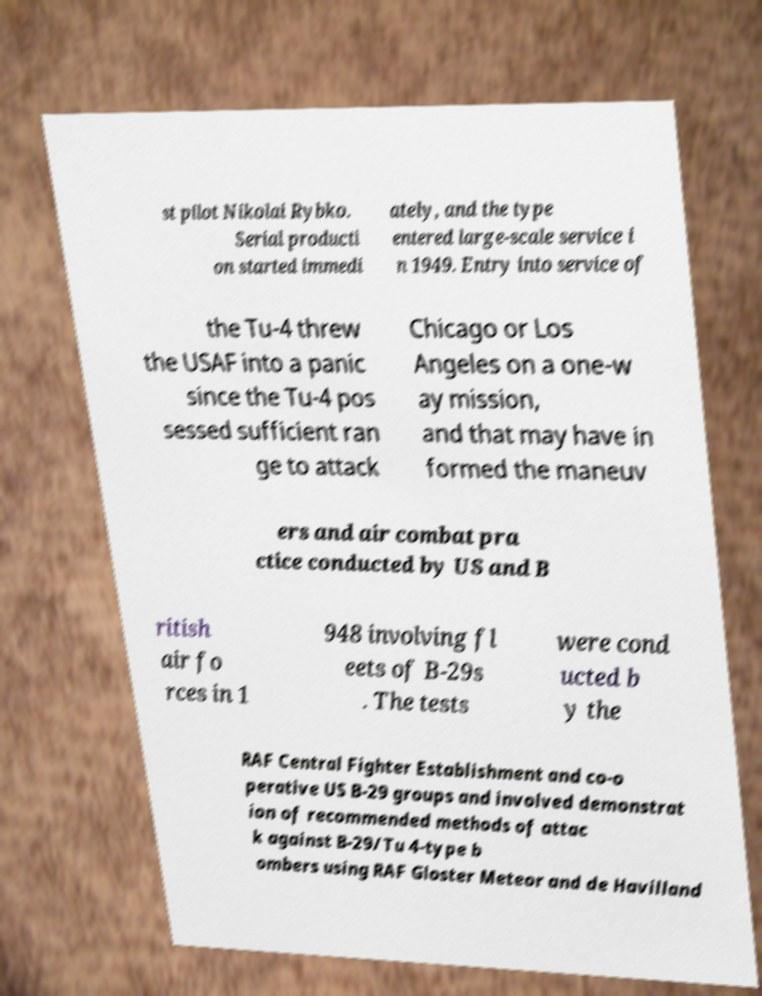Please read and relay the text visible in this image. What does it say? st pilot Nikolai Rybko. Serial producti on started immedi ately, and the type entered large-scale service i n 1949. Entry into service of the Tu-4 threw the USAF into a panic since the Tu-4 pos sessed sufficient ran ge to attack Chicago or Los Angeles on a one-w ay mission, and that may have in formed the maneuv ers and air combat pra ctice conducted by US and B ritish air fo rces in 1 948 involving fl eets of B-29s . The tests were cond ucted b y the RAF Central Fighter Establishment and co-o perative US B-29 groups and involved demonstrat ion of recommended methods of attac k against B-29/Tu 4-type b ombers using RAF Gloster Meteor and de Havilland 